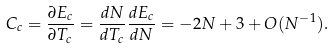<formula> <loc_0><loc_0><loc_500><loc_500>C _ { c } = \frac { \partial E _ { c } } { \partial T _ { c } } = \frac { d N } { d T _ { c } } \frac { d E _ { c } } { d N } = - 2 N + 3 + O ( N ^ { - 1 } ) .</formula> 